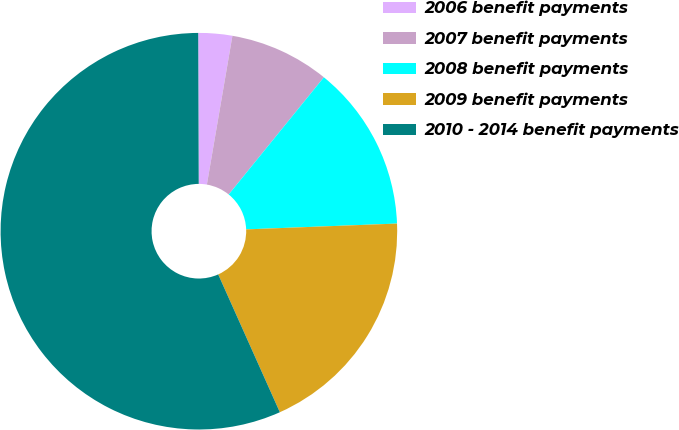<chart> <loc_0><loc_0><loc_500><loc_500><pie_chart><fcel>2006 benefit payments<fcel>2007 benefit payments<fcel>2008 benefit payments<fcel>2009 benefit payments<fcel>2010 - 2014 benefit payments<nl><fcel>2.76%<fcel>8.15%<fcel>13.53%<fcel>18.92%<fcel>56.64%<nl></chart> 